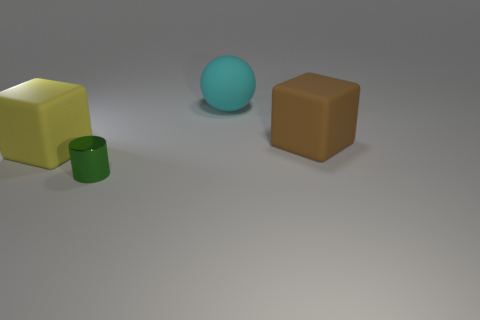Are there any other things that have the same material as the tiny green cylinder?
Provide a short and direct response. No. What is the shape of the thing in front of the large thing that is to the left of the metallic cylinder?
Ensure brevity in your answer.  Cylinder. What color is the large rubber sphere?
Offer a very short reply. Cyan. What number of other objects are there of the same size as the brown cube?
Make the answer very short. 2. There is a object that is behind the small cylinder and left of the large cyan object; what is its material?
Offer a very short reply. Rubber. There is a cube that is left of the sphere; is it the same size as the small metallic thing?
Offer a very short reply. No. Is the rubber sphere the same color as the tiny thing?
Offer a terse response. No. What number of things are right of the yellow rubber block and left of the large cyan object?
Offer a very short reply. 1. There is a big rubber object behind the big rubber object that is to the right of the matte sphere; how many big objects are right of it?
Offer a very short reply. 1. What is the shape of the green thing?
Keep it short and to the point. Cylinder. 